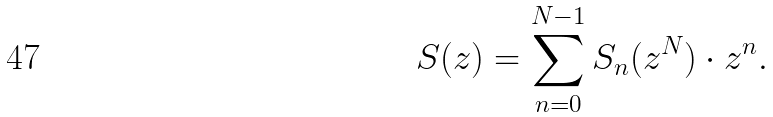<formula> <loc_0><loc_0><loc_500><loc_500>S ( z ) = \sum _ { n = 0 } ^ { N - 1 } S _ { n } ( z ^ { N } ) \cdot z ^ { n } .</formula> 